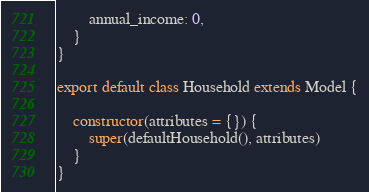<code> <loc_0><loc_0><loc_500><loc_500><_JavaScript_>        annual_income: 0,
    }
}

export default class Household extends Model {

    constructor(attributes = {}) {
        super(defaultHousehold(), attributes)
    }
}</code> 